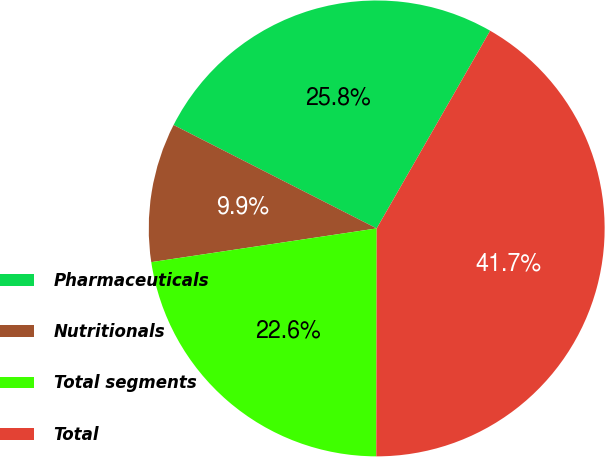<chart> <loc_0><loc_0><loc_500><loc_500><pie_chart><fcel>Pharmaceuticals<fcel>Nutritionals<fcel>Total segments<fcel>Total<nl><fcel>25.8%<fcel>9.86%<fcel>22.61%<fcel>41.74%<nl></chart> 